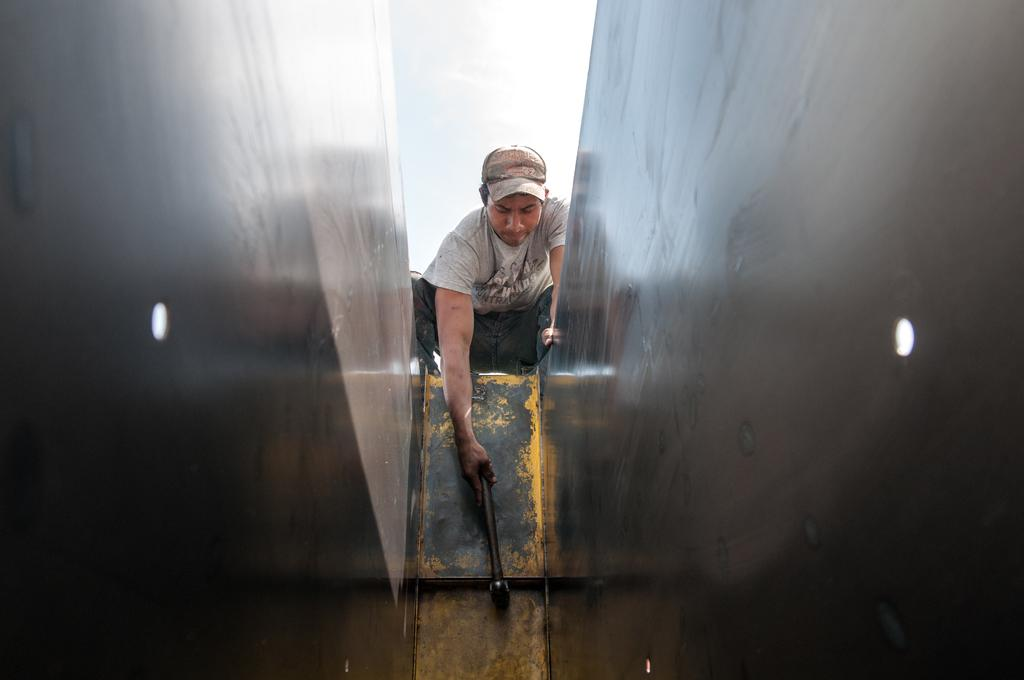What is the man in the image doing? The man is hitting something with a hammer. What type of clothing is the man wearing on his upper body? The man is wearing a t-shirt. What type of clothing is the man wearing on his lower body? The man is wearing trousers. What type of headwear is the man wearing? The man is wearing a cap. Can you tell me how many friends are visible in the image? There is no friend visible in the image; it only features a man. What type of bait is the man using in the image? There is no bait present in the image; the man is using a hammer to hit something. 